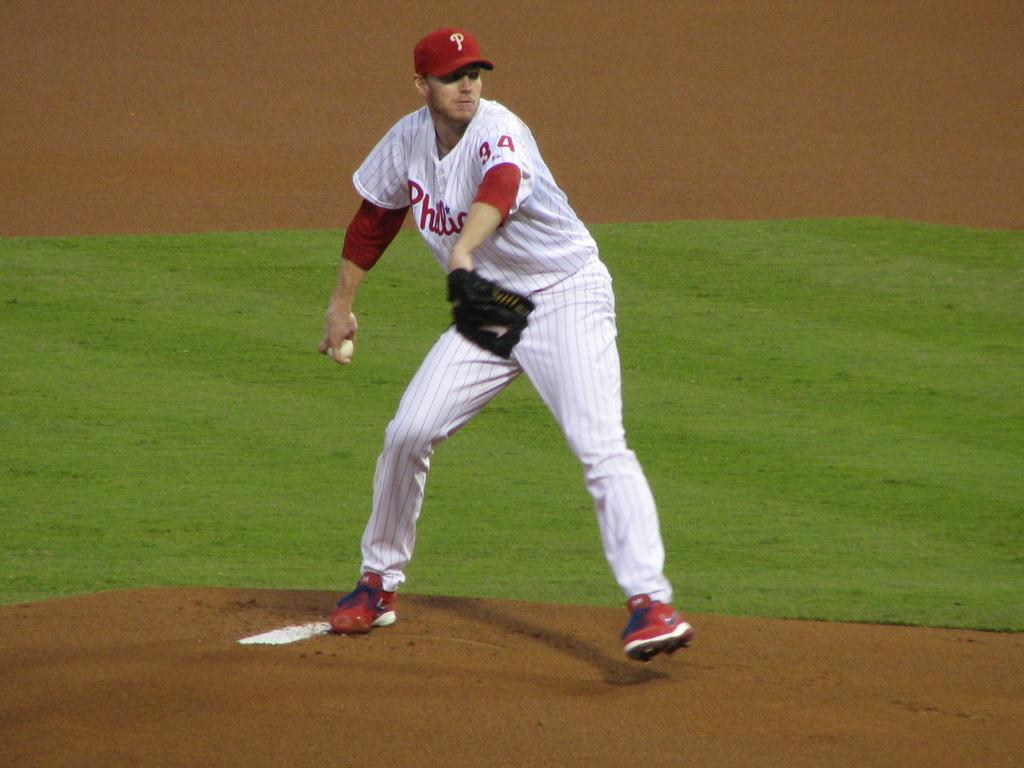<image>
Provide a brief description of the given image. A pitcher for the Phillies stands on the mound. 